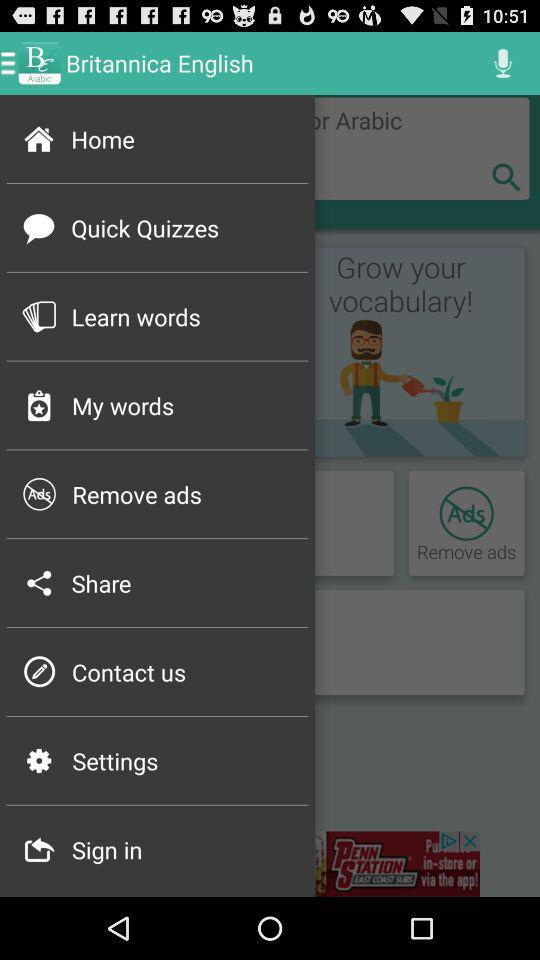What is the name of the application? The name of the application is "Britannica English". 